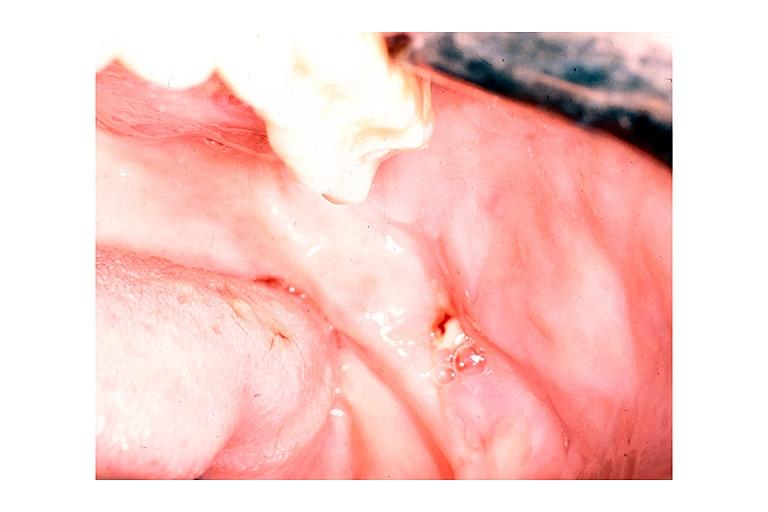s oral present?
Answer the question using a single word or phrase. Yes 